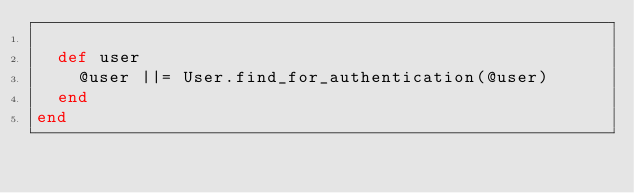Convert code to text. <code><loc_0><loc_0><loc_500><loc_500><_Ruby_>
  def user
    @user ||= User.find_for_authentication(@user)
  end
end
</code> 